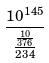<formula> <loc_0><loc_0><loc_500><loc_500>\frac { 1 0 ^ { 1 4 5 } } { \frac { \frac { 1 0 } { 3 7 6 } } { 2 3 4 } }</formula> 